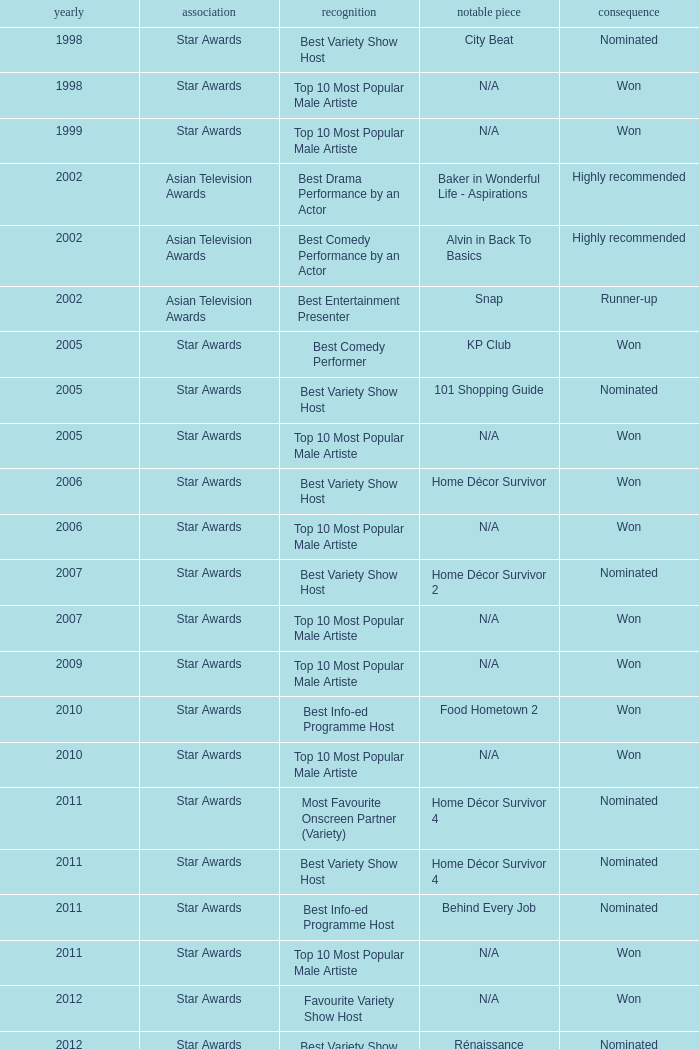What is the name of the award in a year more than 2005, and the Result of nominated? Best Variety Show Host, Most Favourite Onscreen Partner (Variety), Best Variety Show Host, Best Info-ed Programme Host, Best Variety Show Host, Best Info-ed Programme Host, Best Info-Ed Programme Host, Best Variety Show Host. 